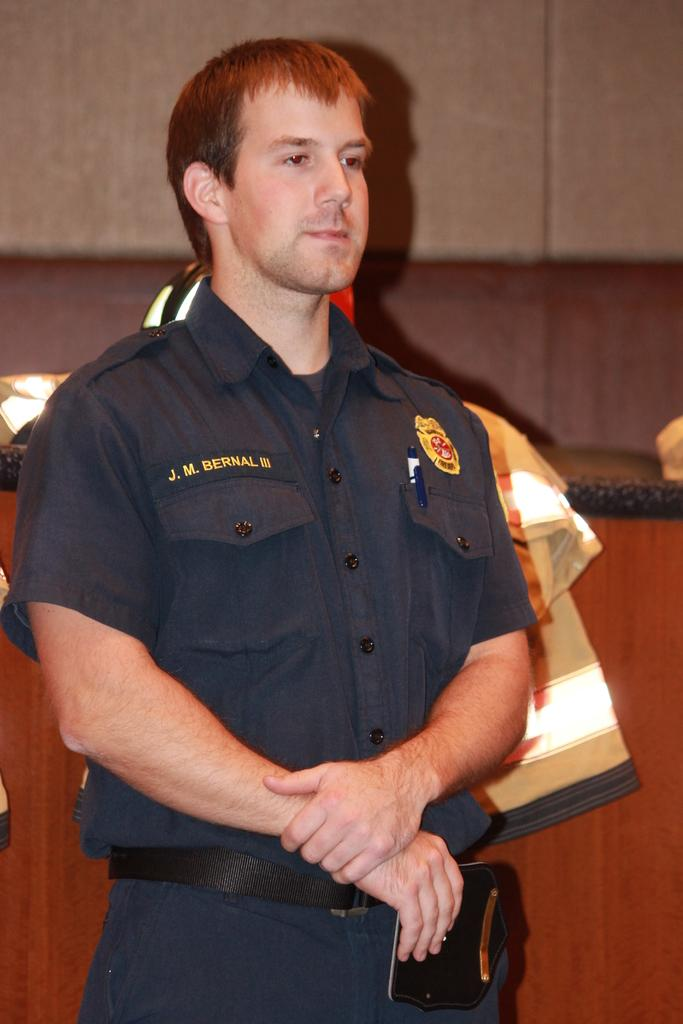What is the main subject in the foreground of the image? There is a person in the foreground of the image. What is the person wearing? The person is wearing a uniform. What is the person's posture in the image? The person is standing. What can be seen in the background of the image? There is a wall and other objects visible in the background of the image. What type of lipstick is the person wearing in the image? There is no lipstick or indication of makeup visible on the person in the image. 